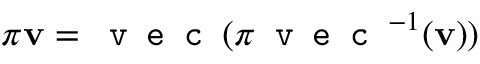Convert formula to latex. <formula><loc_0><loc_0><loc_500><loc_500>\pi v = v e c ( \pi v e c ^ { - 1 } ( v ) )</formula> 